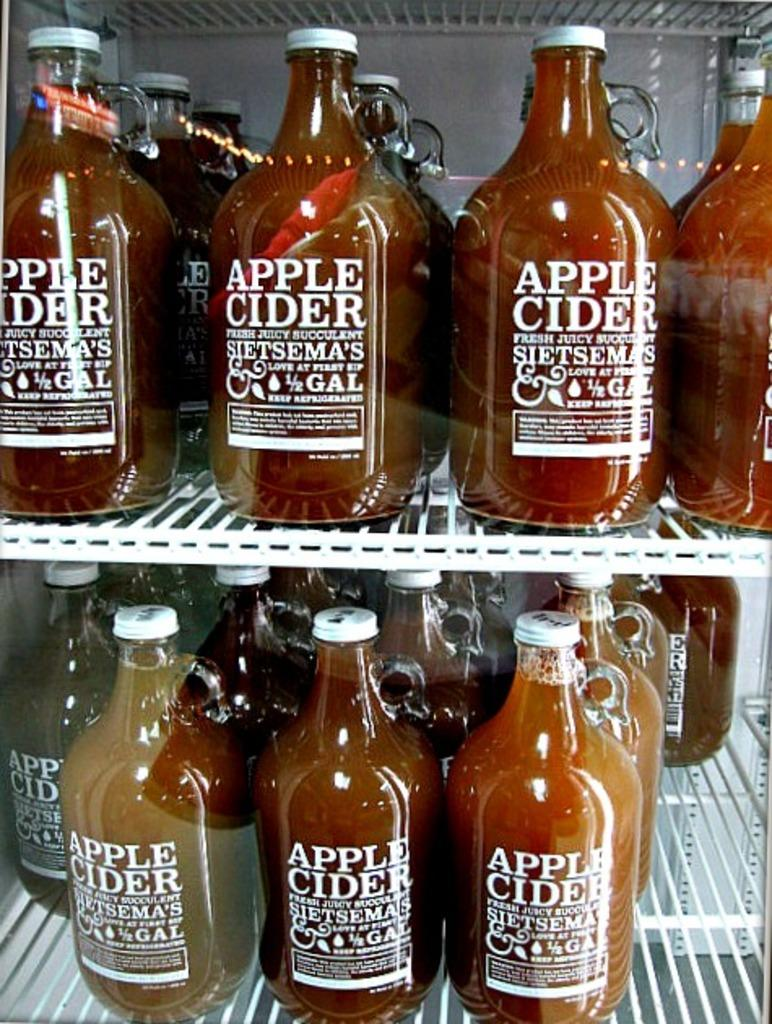<image>
Relay a brief, clear account of the picture shown. Many jars of Apple Cider sit together in a refridgerator. 